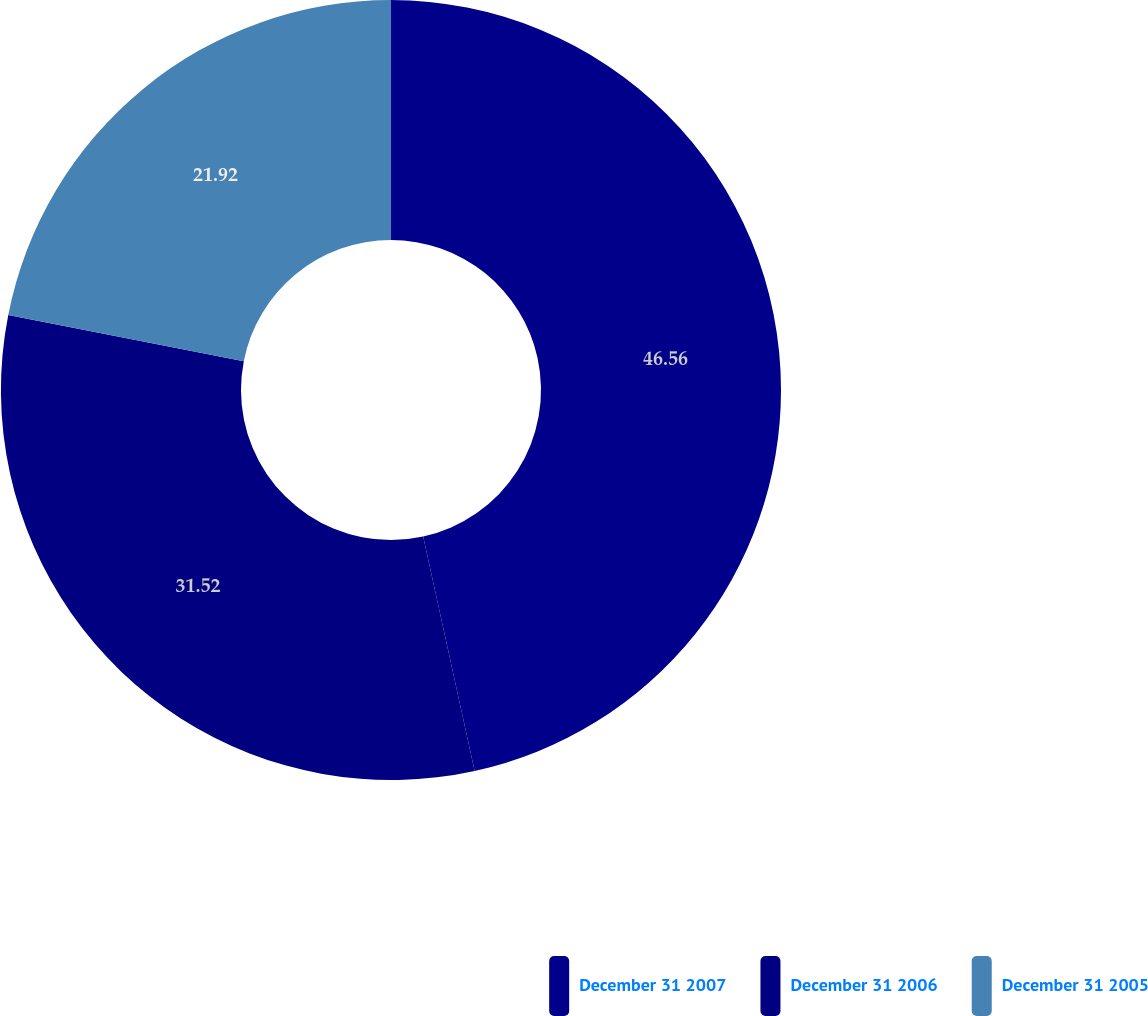Convert chart to OTSL. <chart><loc_0><loc_0><loc_500><loc_500><pie_chart><fcel>December 31 2007<fcel>December 31 2006<fcel>December 31 2005<nl><fcel>46.56%<fcel>31.52%<fcel>21.92%<nl></chart> 